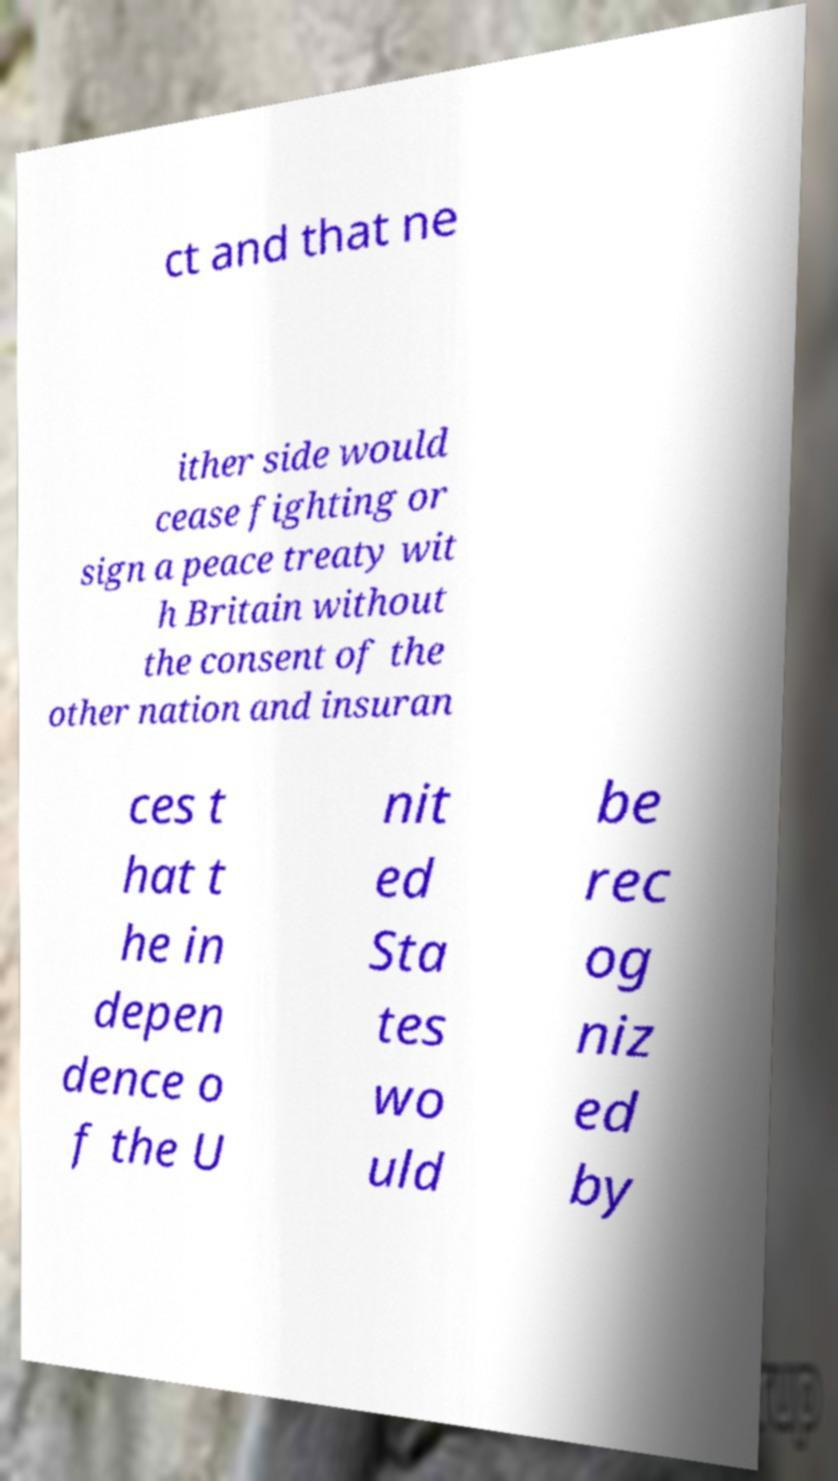There's text embedded in this image that I need extracted. Can you transcribe it verbatim? ct and that ne ither side would cease fighting or sign a peace treaty wit h Britain without the consent of the other nation and insuran ces t hat t he in depen dence o f the U nit ed Sta tes wo uld be rec og niz ed by 